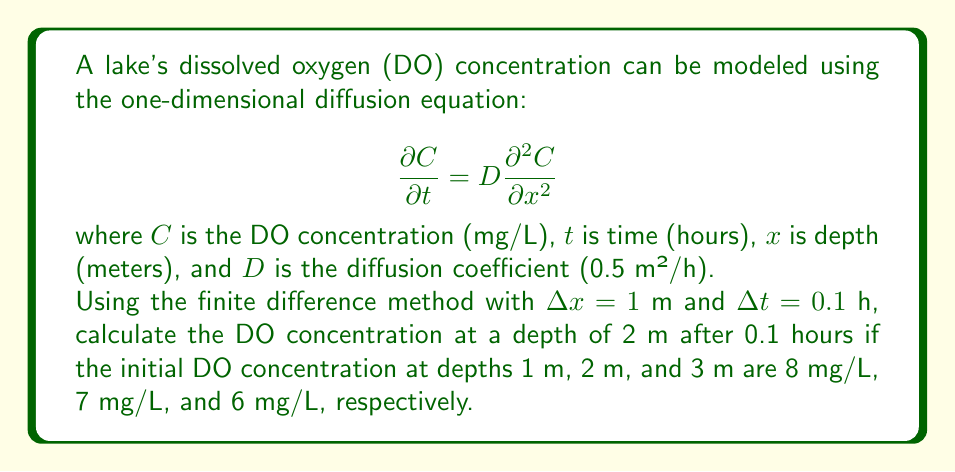What is the answer to this math problem? To solve this problem, we'll use the explicit finite difference method:

1) The finite difference approximation for the diffusion equation is:

   $$C_{i}^{n+1} = C_{i}^{n} + \frac{D\Delta t}{(\Delta x)^2}(C_{i+1}^{n} - 2C_{i}^{n} + C_{i-1}^{n})$$

2) Given:
   - $D = 0.5$ m²/h
   - $\Delta x = 1$ m
   - $\Delta t = 0.1$ h
   - $C_{1}^{0} = 8$ mg/L (1 m depth)
   - $C_{2}^{0} = 7$ mg/L (2 m depth)
   - $C_{3}^{0} = 6$ mg/L (3 m depth)

3) Calculate the coefficient:
   $$\frac{D\Delta t}{(\Delta x)^2} = \frac{0.5 \cdot 0.1}{1^2} = 0.05$$

4) Apply the finite difference equation for the 2 m depth (i = 2):

   $$C_{2}^{1} = C_{2}^{0} + 0.05(C_{3}^{0} - 2C_{2}^{0} + C_{1}^{0})$$

5) Substitute the values:

   $$C_{2}^{1} = 7 + 0.05(6 - 2(7) + 8)$$

6) Simplify:

   $$C_{2}^{1} = 7 + 0.05(6 - 14 + 8) = 7 + 0.05(0) = 7$$

Therefore, the DO concentration at 2 m depth after 0.1 hours remains 7 mg/L.
Answer: 7 mg/L 